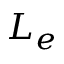Convert formula to latex. <formula><loc_0><loc_0><loc_500><loc_500>L _ { e }</formula> 